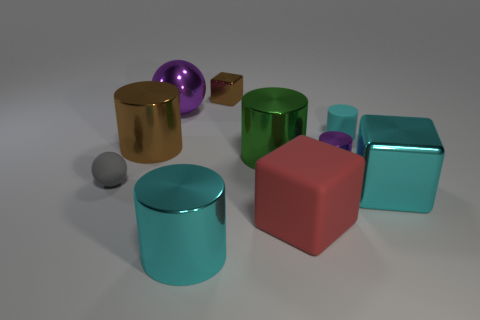What might be the material of the objects, judging by their appearance? The objects seem to be made from materials that have distinct visual properties. The reflective nature of the purple sphere suggests it could be made of a polished metal or plastic. The brown cube looks matte, possibly resembling wood. The red and cyan objects have a slight sheen, which could indicate a plastic or painted metal. The gold object has a metallic luster, suggesting it could be a polished metal. These observations are based on their appearance, but without further tactile or compositional information, it is difficult to determine the exact materials. 